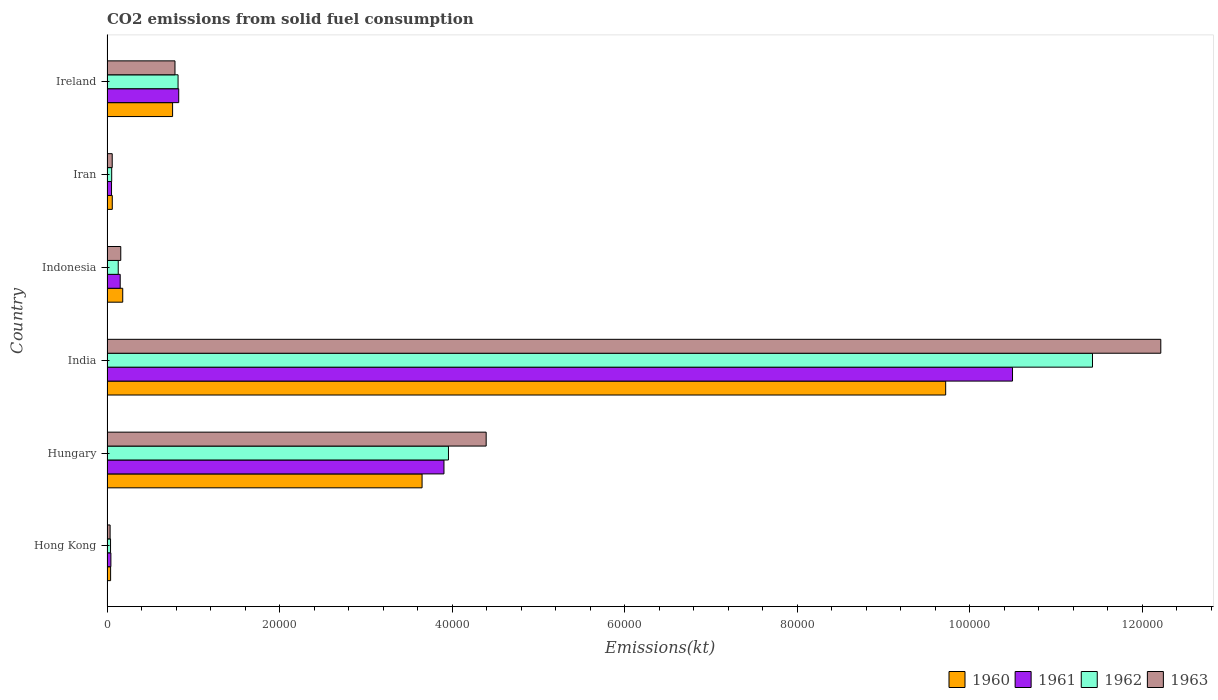How many different coloured bars are there?
Provide a short and direct response. 4. Are the number of bars on each tick of the Y-axis equal?
Your answer should be very brief. Yes. How many bars are there on the 3rd tick from the bottom?
Offer a terse response. 4. What is the amount of CO2 emitted in 1961 in India?
Give a very brief answer. 1.05e+05. Across all countries, what is the maximum amount of CO2 emitted in 1961?
Your response must be concise. 1.05e+05. Across all countries, what is the minimum amount of CO2 emitted in 1963?
Keep it short and to the point. 359.37. In which country was the amount of CO2 emitted in 1961 minimum?
Keep it short and to the point. Hong Kong. What is the total amount of CO2 emitted in 1960 in the graph?
Ensure brevity in your answer.  1.44e+05. What is the difference between the amount of CO2 emitted in 1960 in Hong Kong and that in Indonesia?
Provide a short and direct response. -1404.46. What is the difference between the amount of CO2 emitted in 1962 in India and the amount of CO2 emitted in 1960 in Hungary?
Give a very brief answer. 7.77e+04. What is the average amount of CO2 emitted in 1963 per country?
Make the answer very short. 2.94e+04. What is the difference between the amount of CO2 emitted in 1961 and amount of CO2 emitted in 1963 in India?
Provide a short and direct response. -1.72e+04. In how many countries, is the amount of CO2 emitted in 1961 greater than 92000 kt?
Keep it short and to the point. 1. What is the ratio of the amount of CO2 emitted in 1961 in Hungary to that in Indonesia?
Provide a short and direct response. 25.54. Is the amount of CO2 emitted in 1960 in India less than that in Indonesia?
Ensure brevity in your answer.  No. Is the difference between the amount of CO2 emitted in 1961 in India and Iran greater than the difference between the amount of CO2 emitted in 1963 in India and Iran?
Ensure brevity in your answer.  No. What is the difference between the highest and the second highest amount of CO2 emitted in 1962?
Ensure brevity in your answer.  7.46e+04. What is the difference between the highest and the lowest amount of CO2 emitted in 1963?
Your answer should be compact. 1.22e+05. Is the sum of the amount of CO2 emitted in 1963 in India and Iran greater than the maximum amount of CO2 emitted in 1961 across all countries?
Ensure brevity in your answer.  Yes. Is it the case that in every country, the sum of the amount of CO2 emitted in 1963 and amount of CO2 emitted in 1961 is greater than the sum of amount of CO2 emitted in 1962 and amount of CO2 emitted in 1960?
Provide a succinct answer. No. What does the 4th bar from the bottom in Iran represents?
Offer a terse response. 1963. Is it the case that in every country, the sum of the amount of CO2 emitted in 1960 and amount of CO2 emitted in 1962 is greater than the amount of CO2 emitted in 1963?
Offer a very short reply. Yes. Are the values on the major ticks of X-axis written in scientific E-notation?
Ensure brevity in your answer.  No. What is the title of the graph?
Your answer should be compact. CO2 emissions from solid fuel consumption. What is the label or title of the X-axis?
Your response must be concise. Emissions(kt). What is the Emissions(kt) of 1960 in Hong Kong?
Give a very brief answer. 418.04. What is the Emissions(kt) in 1961 in Hong Kong?
Make the answer very short. 451.04. What is the Emissions(kt) in 1962 in Hong Kong?
Your response must be concise. 410.7. What is the Emissions(kt) of 1963 in Hong Kong?
Give a very brief answer. 359.37. What is the Emissions(kt) of 1960 in Hungary?
Make the answer very short. 3.65e+04. What is the Emissions(kt) of 1961 in Hungary?
Give a very brief answer. 3.91e+04. What is the Emissions(kt) in 1962 in Hungary?
Offer a terse response. 3.96e+04. What is the Emissions(kt) in 1963 in Hungary?
Offer a very short reply. 4.39e+04. What is the Emissions(kt) in 1960 in India?
Your answer should be compact. 9.72e+04. What is the Emissions(kt) in 1961 in India?
Your answer should be very brief. 1.05e+05. What is the Emissions(kt) in 1962 in India?
Ensure brevity in your answer.  1.14e+05. What is the Emissions(kt) in 1963 in India?
Make the answer very short. 1.22e+05. What is the Emissions(kt) in 1960 in Indonesia?
Offer a terse response. 1822.5. What is the Emissions(kt) in 1961 in Indonesia?
Give a very brief answer. 1529.14. What is the Emissions(kt) in 1962 in Indonesia?
Your answer should be very brief. 1301.79. What is the Emissions(kt) in 1963 in Indonesia?
Keep it short and to the point. 1595.14. What is the Emissions(kt) in 1960 in Iran?
Offer a terse response. 612.39. What is the Emissions(kt) in 1961 in Iran?
Keep it short and to the point. 524.38. What is the Emissions(kt) in 1962 in Iran?
Provide a succinct answer. 542.72. What is the Emissions(kt) of 1963 in Iran?
Make the answer very short. 605.05. What is the Emissions(kt) of 1960 in Ireland?
Provide a short and direct response. 7601.69. What is the Emissions(kt) of 1961 in Ireland?
Offer a very short reply. 8313.09. What is the Emissions(kt) of 1962 in Ireland?
Offer a very short reply. 8236.08. What is the Emissions(kt) in 1963 in Ireland?
Provide a succinct answer. 7880.38. Across all countries, what is the maximum Emissions(kt) in 1960?
Ensure brevity in your answer.  9.72e+04. Across all countries, what is the maximum Emissions(kt) of 1961?
Your response must be concise. 1.05e+05. Across all countries, what is the maximum Emissions(kt) in 1962?
Offer a terse response. 1.14e+05. Across all countries, what is the maximum Emissions(kt) of 1963?
Provide a short and direct response. 1.22e+05. Across all countries, what is the minimum Emissions(kt) of 1960?
Your answer should be very brief. 418.04. Across all countries, what is the minimum Emissions(kt) in 1961?
Provide a short and direct response. 451.04. Across all countries, what is the minimum Emissions(kt) of 1962?
Make the answer very short. 410.7. Across all countries, what is the minimum Emissions(kt) in 1963?
Make the answer very short. 359.37. What is the total Emissions(kt) in 1960 in the graph?
Provide a short and direct response. 1.44e+05. What is the total Emissions(kt) in 1961 in the graph?
Make the answer very short. 1.55e+05. What is the total Emissions(kt) in 1962 in the graph?
Your answer should be compact. 1.64e+05. What is the total Emissions(kt) in 1963 in the graph?
Offer a very short reply. 1.77e+05. What is the difference between the Emissions(kt) of 1960 in Hong Kong and that in Hungary?
Your answer should be very brief. -3.61e+04. What is the difference between the Emissions(kt) in 1961 in Hong Kong and that in Hungary?
Keep it short and to the point. -3.86e+04. What is the difference between the Emissions(kt) in 1962 in Hong Kong and that in Hungary?
Offer a terse response. -3.92e+04. What is the difference between the Emissions(kt) of 1963 in Hong Kong and that in Hungary?
Keep it short and to the point. -4.36e+04. What is the difference between the Emissions(kt) in 1960 in Hong Kong and that in India?
Keep it short and to the point. -9.68e+04. What is the difference between the Emissions(kt) of 1961 in Hong Kong and that in India?
Ensure brevity in your answer.  -1.05e+05. What is the difference between the Emissions(kt) of 1962 in Hong Kong and that in India?
Offer a very short reply. -1.14e+05. What is the difference between the Emissions(kt) of 1963 in Hong Kong and that in India?
Your answer should be very brief. -1.22e+05. What is the difference between the Emissions(kt) in 1960 in Hong Kong and that in Indonesia?
Your response must be concise. -1404.46. What is the difference between the Emissions(kt) of 1961 in Hong Kong and that in Indonesia?
Your response must be concise. -1078.1. What is the difference between the Emissions(kt) of 1962 in Hong Kong and that in Indonesia?
Offer a terse response. -891.08. What is the difference between the Emissions(kt) in 1963 in Hong Kong and that in Indonesia?
Your response must be concise. -1235.78. What is the difference between the Emissions(kt) of 1960 in Hong Kong and that in Iran?
Offer a very short reply. -194.35. What is the difference between the Emissions(kt) of 1961 in Hong Kong and that in Iran?
Ensure brevity in your answer.  -73.34. What is the difference between the Emissions(kt) of 1962 in Hong Kong and that in Iran?
Provide a succinct answer. -132.01. What is the difference between the Emissions(kt) of 1963 in Hong Kong and that in Iran?
Your answer should be compact. -245.69. What is the difference between the Emissions(kt) in 1960 in Hong Kong and that in Ireland?
Your answer should be very brief. -7183.65. What is the difference between the Emissions(kt) of 1961 in Hong Kong and that in Ireland?
Give a very brief answer. -7862.05. What is the difference between the Emissions(kt) of 1962 in Hong Kong and that in Ireland?
Your response must be concise. -7825.38. What is the difference between the Emissions(kt) of 1963 in Hong Kong and that in Ireland?
Make the answer very short. -7521.02. What is the difference between the Emissions(kt) in 1960 in Hungary and that in India?
Provide a short and direct response. -6.07e+04. What is the difference between the Emissions(kt) of 1961 in Hungary and that in India?
Your response must be concise. -6.59e+04. What is the difference between the Emissions(kt) of 1962 in Hungary and that in India?
Give a very brief answer. -7.46e+04. What is the difference between the Emissions(kt) of 1963 in Hungary and that in India?
Your response must be concise. -7.82e+04. What is the difference between the Emissions(kt) in 1960 in Hungary and that in Indonesia?
Ensure brevity in your answer.  3.47e+04. What is the difference between the Emissions(kt) of 1961 in Hungary and that in Indonesia?
Your answer should be very brief. 3.75e+04. What is the difference between the Emissions(kt) in 1962 in Hungary and that in Indonesia?
Provide a short and direct response. 3.83e+04. What is the difference between the Emissions(kt) in 1963 in Hungary and that in Indonesia?
Keep it short and to the point. 4.24e+04. What is the difference between the Emissions(kt) of 1960 in Hungary and that in Iran?
Make the answer very short. 3.59e+04. What is the difference between the Emissions(kt) in 1961 in Hungary and that in Iran?
Provide a short and direct response. 3.85e+04. What is the difference between the Emissions(kt) in 1962 in Hungary and that in Iran?
Your answer should be compact. 3.90e+04. What is the difference between the Emissions(kt) of 1963 in Hungary and that in Iran?
Offer a terse response. 4.33e+04. What is the difference between the Emissions(kt) in 1960 in Hungary and that in Ireland?
Your response must be concise. 2.89e+04. What is the difference between the Emissions(kt) of 1961 in Hungary and that in Ireland?
Your answer should be compact. 3.07e+04. What is the difference between the Emissions(kt) of 1962 in Hungary and that in Ireland?
Your answer should be very brief. 3.13e+04. What is the difference between the Emissions(kt) of 1963 in Hungary and that in Ireland?
Your answer should be very brief. 3.61e+04. What is the difference between the Emissions(kt) in 1960 in India and that in Indonesia?
Your answer should be very brief. 9.54e+04. What is the difference between the Emissions(kt) in 1961 in India and that in Indonesia?
Your answer should be very brief. 1.03e+05. What is the difference between the Emissions(kt) in 1962 in India and that in Indonesia?
Your response must be concise. 1.13e+05. What is the difference between the Emissions(kt) in 1963 in India and that in Indonesia?
Provide a succinct answer. 1.21e+05. What is the difference between the Emissions(kt) of 1960 in India and that in Iran?
Keep it short and to the point. 9.66e+04. What is the difference between the Emissions(kt) of 1961 in India and that in Iran?
Provide a short and direct response. 1.04e+05. What is the difference between the Emissions(kt) in 1962 in India and that in Iran?
Offer a terse response. 1.14e+05. What is the difference between the Emissions(kt) of 1963 in India and that in Iran?
Your answer should be very brief. 1.22e+05. What is the difference between the Emissions(kt) in 1960 in India and that in Ireland?
Your answer should be compact. 8.96e+04. What is the difference between the Emissions(kt) in 1961 in India and that in Ireland?
Your answer should be compact. 9.66e+04. What is the difference between the Emissions(kt) of 1962 in India and that in Ireland?
Offer a terse response. 1.06e+05. What is the difference between the Emissions(kt) in 1963 in India and that in Ireland?
Your answer should be very brief. 1.14e+05. What is the difference between the Emissions(kt) in 1960 in Indonesia and that in Iran?
Provide a succinct answer. 1210.11. What is the difference between the Emissions(kt) of 1961 in Indonesia and that in Iran?
Give a very brief answer. 1004.76. What is the difference between the Emissions(kt) in 1962 in Indonesia and that in Iran?
Your response must be concise. 759.07. What is the difference between the Emissions(kt) of 1963 in Indonesia and that in Iran?
Your answer should be compact. 990.09. What is the difference between the Emissions(kt) of 1960 in Indonesia and that in Ireland?
Provide a short and direct response. -5779.19. What is the difference between the Emissions(kt) in 1961 in Indonesia and that in Ireland?
Make the answer very short. -6783.95. What is the difference between the Emissions(kt) in 1962 in Indonesia and that in Ireland?
Your response must be concise. -6934.3. What is the difference between the Emissions(kt) of 1963 in Indonesia and that in Ireland?
Give a very brief answer. -6285.24. What is the difference between the Emissions(kt) of 1960 in Iran and that in Ireland?
Make the answer very short. -6989.3. What is the difference between the Emissions(kt) in 1961 in Iran and that in Ireland?
Provide a succinct answer. -7788.71. What is the difference between the Emissions(kt) of 1962 in Iran and that in Ireland?
Your response must be concise. -7693.37. What is the difference between the Emissions(kt) in 1963 in Iran and that in Ireland?
Your response must be concise. -7275.33. What is the difference between the Emissions(kt) of 1960 in Hong Kong and the Emissions(kt) of 1961 in Hungary?
Your response must be concise. -3.86e+04. What is the difference between the Emissions(kt) in 1960 in Hong Kong and the Emissions(kt) in 1962 in Hungary?
Make the answer very short. -3.92e+04. What is the difference between the Emissions(kt) in 1960 in Hong Kong and the Emissions(kt) in 1963 in Hungary?
Provide a succinct answer. -4.35e+04. What is the difference between the Emissions(kt) in 1961 in Hong Kong and the Emissions(kt) in 1962 in Hungary?
Give a very brief answer. -3.91e+04. What is the difference between the Emissions(kt) in 1961 in Hong Kong and the Emissions(kt) in 1963 in Hungary?
Give a very brief answer. -4.35e+04. What is the difference between the Emissions(kt) in 1962 in Hong Kong and the Emissions(kt) in 1963 in Hungary?
Your answer should be very brief. -4.35e+04. What is the difference between the Emissions(kt) of 1960 in Hong Kong and the Emissions(kt) of 1961 in India?
Your answer should be very brief. -1.05e+05. What is the difference between the Emissions(kt) of 1960 in Hong Kong and the Emissions(kt) of 1962 in India?
Give a very brief answer. -1.14e+05. What is the difference between the Emissions(kt) of 1960 in Hong Kong and the Emissions(kt) of 1963 in India?
Make the answer very short. -1.22e+05. What is the difference between the Emissions(kt) in 1961 in Hong Kong and the Emissions(kt) in 1962 in India?
Offer a terse response. -1.14e+05. What is the difference between the Emissions(kt) in 1961 in Hong Kong and the Emissions(kt) in 1963 in India?
Keep it short and to the point. -1.22e+05. What is the difference between the Emissions(kt) of 1962 in Hong Kong and the Emissions(kt) of 1963 in India?
Give a very brief answer. -1.22e+05. What is the difference between the Emissions(kt) of 1960 in Hong Kong and the Emissions(kt) of 1961 in Indonesia?
Give a very brief answer. -1111.1. What is the difference between the Emissions(kt) of 1960 in Hong Kong and the Emissions(kt) of 1962 in Indonesia?
Make the answer very short. -883.75. What is the difference between the Emissions(kt) of 1960 in Hong Kong and the Emissions(kt) of 1963 in Indonesia?
Offer a very short reply. -1177.11. What is the difference between the Emissions(kt) in 1961 in Hong Kong and the Emissions(kt) in 1962 in Indonesia?
Offer a terse response. -850.74. What is the difference between the Emissions(kt) in 1961 in Hong Kong and the Emissions(kt) in 1963 in Indonesia?
Ensure brevity in your answer.  -1144.1. What is the difference between the Emissions(kt) in 1962 in Hong Kong and the Emissions(kt) in 1963 in Indonesia?
Your response must be concise. -1184.44. What is the difference between the Emissions(kt) of 1960 in Hong Kong and the Emissions(kt) of 1961 in Iran?
Make the answer very short. -106.34. What is the difference between the Emissions(kt) of 1960 in Hong Kong and the Emissions(kt) of 1962 in Iran?
Provide a short and direct response. -124.68. What is the difference between the Emissions(kt) of 1960 in Hong Kong and the Emissions(kt) of 1963 in Iran?
Give a very brief answer. -187.02. What is the difference between the Emissions(kt) of 1961 in Hong Kong and the Emissions(kt) of 1962 in Iran?
Give a very brief answer. -91.67. What is the difference between the Emissions(kt) of 1961 in Hong Kong and the Emissions(kt) of 1963 in Iran?
Give a very brief answer. -154.01. What is the difference between the Emissions(kt) of 1962 in Hong Kong and the Emissions(kt) of 1963 in Iran?
Offer a very short reply. -194.35. What is the difference between the Emissions(kt) of 1960 in Hong Kong and the Emissions(kt) of 1961 in Ireland?
Keep it short and to the point. -7895.05. What is the difference between the Emissions(kt) in 1960 in Hong Kong and the Emissions(kt) in 1962 in Ireland?
Your answer should be very brief. -7818.04. What is the difference between the Emissions(kt) in 1960 in Hong Kong and the Emissions(kt) in 1963 in Ireland?
Make the answer very short. -7462.35. What is the difference between the Emissions(kt) in 1961 in Hong Kong and the Emissions(kt) in 1962 in Ireland?
Make the answer very short. -7785.04. What is the difference between the Emissions(kt) in 1961 in Hong Kong and the Emissions(kt) in 1963 in Ireland?
Ensure brevity in your answer.  -7429.34. What is the difference between the Emissions(kt) of 1962 in Hong Kong and the Emissions(kt) of 1963 in Ireland?
Ensure brevity in your answer.  -7469.68. What is the difference between the Emissions(kt) in 1960 in Hungary and the Emissions(kt) in 1961 in India?
Make the answer very short. -6.84e+04. What is the difference between the Emissions(kt) of 1960 in Hungary and the Emissions(kt) of 1962 in India?
Offer a terse response. -7.77e+04. What is the difference between the Emissions(kt) of 1960 in Hungary and the Emissions(kt) of 1963 in India?
Your answer should be very brief. -8.56e+04. What is the difference between the Emissions(kt) of 1961 in Hungary and the Emissions(kt) of 1962 in India?
Offer a very short reply. -7.52e+04. What is the difference between the Emissions(kt) in 1961 in Hungary and the Emissions(kt) in 1963 in India?
Ensure brevity in your answer.  -8.31e+04. What is the difference between the Emissions(kt) of 1962 in Hungary and the Emissions(kt) of 1963 in India?
Offer a very short reply. -8.26e+04. What is the difference between the Emissions(kt) of 1960 in Hungary and the Emissions(kt) of 1961 in Indonesia?
Your response must be concise. 3.50e+04. What is the difference between the Emissions(kt) in 1960 in Hungary and the Emissions(kt) in 1962 in Indonesia?
Offer a very short reply. 3.52e+04. What is the difference between the Emissions(kt) of 1960 in Hungary and the Emissions(kt) of 1963 in Indonesia?
Make the answer very short. 3.49e+04. What is the difference between the Emissions(kt) in 1961 in Hungary and the Emissions(kt) in 1962 in Indonesia?
Provide a short and direct response. 3.78e+04. What is the difference between the Emissions(kt) in 1961 in Hungary and the Emissions(kt) in 1963 in Indonesia?
Offer a very short reply. 3.75e+04. What is the difference between the Emissions(kt) in 1962 in Hungary and the Emissions(kt) in 1963 in Indonesia?
Ensure brevity in your answer.  3.80e+04. What is the difference between the Emissions(kt) of 1960 in Hungary and the Emissions(kt) of 1961 in Iran?
Ensure brevity in your answer.  3.60e+04. What is the difference between the Emissions(kt) in 1960 in Hungary and the Emissions(kt) in 1962 in Iran?
Ensure brevity in your answer.  3.60e+04. What is the difference between the Emissions(kt) in 1960 in Hungary and the Emissions(kt) in 1963 in Iran?
Your answer should be very brief. 3.59e+04. What is the difference between the Emissions(kt) in 1961 in Hungary and the Emissions(kt) in 1962 in Iran?
Offer a very short reply. 3.85e+04. What is the difference between the Emissions(kt) of 1961 in Hungary and the Emissions(kt) of 1963 in Iran?
Make the answer very short. 3.85e+04. What is the difference between the Emissions(kt) in 1962 in Hungary and the Emissions(kt) in 1963 in Iran?
Provide a short and direct response. 3.90e+04. What is the difference between the Emissions(kt) in 1960 in Hungary and the Emissions(kt) in 1961 in Ireland?
Keep it short and to the point. 2.82e+04. What is the difference between the Emissions(kt) of 1960 in Hungary and the Emissions(kt) of 1962 in Ireland?
Provide a short and direct response. 2.83e+04. What is the difference between the Emissions(kt) in 1960 in Hungary and the Emissions(kt) in 1963 in Ireland?
Your response must be concise. 2.86e+04. What is the difference between the Emissions(kt) in 1961 in Hungary and the Emissions(kt) in 1962 in Ireland?
Your response must be concise. 3.08e+04. What is the difference between the Emissions(kt) of 1961 in Hungary and the Emissions(kt) of 1963 in Ireland?
Offer a very short reply. 3.12e+04. What is the difference between the Emissions(kt) of 1962 in Hungary and the Emissions(kt) of 1963 in Ireland?
Make the answer very short. 3.17e+04. What is the difference between the Emissions(kt) in 1960 in India and the Emissions(kt) in 1961 in Indonesia?
Make the answer very short. 9.57e+04. What is the difference between the Emissions(kt) in 1960 in India and the Emissions(kt) in 1962 in Indonesia?
Keep it short and to the point. 9.59e+04. What is the difference between the Emissions(kt) of 1960 in India and the Emissions(kt) of 1963 in Indonesia?
Your answer should be compact. 9.56e+04. What is the difference between the Emissions(kt) in 1961 in India and the Emissions(kt) in 1962 in Indonesia?
Your answer should be very brief. 1.04e+05. What is the difference between the Emissions(kt) in 1961 in India and the Emissions(kt) in 1963 in Indonesia?
Make the answer very short. 1.03e+05. What is the difference between the Emissions(kt) in 1962 in India and the Emissions(kt) in 1963 in Indonesia?
Provide a short and direct response. 1.13e+05. What is the difference between the Emissions(kt) of 1960 in India and the Emissions(kt) of 1961 in Iran?
Keep it short and to the point. 9.67e+04. What is the difference between the Emissions(kt) in 1960 in India and the Emissions(kt) in 1962 in Iran?
Your response must be concise. 9.67e+04. What is the difference between the Emissions(kt) in 1960 in India and the Emissions(kt) in 1963 in Iran?
Your answer should be compact. 9.66e+04. What is the difference between the Emissions(kt) in 1961 in India and the Emissions(kt) in 1962 in Iran?
Offer a terse response. 1.04e+05. What is the difference between the Emissions(kt) of 1961 in India and the Emissions(kt) of 1963 in Iran?
Keep it short and to the point. 1.04e+05. What is the difference between the Emissions(kt) in 1962 in India and the Emissions(kt) in 1963 in Iran?
Provide a short and direct response. 1.14e+05. What is the difference between the Emissions(kt) of 1960 in India and the Emissions(kt) of 1961 in Ireland?
Make the answer very short. 8.89e+04. What is the difference between the Emissions(kt) of 1960 in India and the Emissions(kt) of 1962 in Ireland?
Make the answer very short. 8.90e+04. What is the difference between the Emissions(kt) of 1960 in India and the Emissions(kt) of 1963 in Ireland?
Offer a very short reply. 8.93e+04. What is the difference between the Emissions(kt) of 1961 in India and the Emissions(kt) of 1962 in Ireland?
Your answer should be very brief. 9.67e+04. What is the difference between the Emissions(kt) in 1961 in India and the Emissions(kt) in 1963 in Ireland?
Keep it short and to the point. 9.71e+04. What is the difference between the Emissions(kt) in 1962 in India and the Emissions(kt) in 1963 in Ireland?
Keep it short and to the point. 1.06e+05. What is the difference between the Emissions(kt) of 1960 in Indonesia and the Emissions(kt) of 1961 in Iran?
Make the answer very short. 1298.12. What is the difference between the Emissions(kt) in 1960 in Indonesia and the Emissions(kt) in 1962 in Iran?
Provide a succinct answer. 1279.78. What is the difference between the Emissions(kt) in 1960 in Indonesia and the Emissions(kt) in 1963 in Iran?
Your answer should be very brief. 1217.44. What is the difference between the Emissions(kt) of 1961 in Indonesia and the Emissions(kt) of 1962 in Iran?
Your answer should be compact. 986.42. What is the difference between the Emissions(kt) of 1961 in Indonesia and the Emissions(kt) of 1963 in Iran?
Provide a succinct answer. 924.08. What is the difference between the Emissions(kt) of 1962 in Indonesia and the Emissions(kt) of 1963 in Iran?
Provide a succinct answer. 696.73. What is the difference between the Emissions(kt) in 1960 in Indonesia and the Emissions(kt) in 1961 in Ireland?
Your answer should be very brief. -6490.59. What is the difference between the Emissions(kt) of 1960 in Indonesia and the Emissions(kt) of 1962 in Ireland?
Offer a terse response. -6413.58. What is the difference between the Emissions(kt) in 1960 in Indonesia and the Emissions(kt) in 1963 in Ireland?
Ensure brevity in your answer.  -6057.88. What is the difference between the Emissions(kt) in 1961 in Indonesia and the Emissions(kt) in 1962 in Ireland?
Ensure brevity in your answer.  -6706.94. What is the difference between the Emissions(kt) of 1961 in Indonesia and the Emissions(kt) of 1963 in Ireland?
Keep it short and to the point. -6351.24. What is the difference between the Emissions(kt) in 1962 in Indonesia and the Emissions(kt) in 1963 in Ireland?
Your answer should be very brief. -6578.6. What is the difference between the Emissions(kt) in 1960 in Iran and the Emissions(kt) in 1961 in Ireland?
Offer a very short reply. -7700.7. What is the difference between the Emissions(kt) in 1960 in Iran and the Emissions(kt) in 1962 in Ireland?
Your answer should be very brief. -7623.69. What is the difference between the Emissions(kt) in 1960 in Iran and the Emissions(kt) in 1963 in Ireland?
Ensure brevity in your answer.  -7267.99. What is the difference between the Emissions(kt) in 1961 in Iran and the Emissions(kt) in 1962 in Ireland?
Provide a succinct answer. -7711.7. What is the difference between the Emissions(kt) in 1961 in Iran and the Emissions(kt) in 1963 in Ireland?
Provide a succinct answer. -7356. What is the difference between the Emissions(kt) in 1962 in Iran and the Emissions(kt) in 1963 in Ireland?
Your answer should be compact. -7337.67. What is the average Emissions(kt) of 1960 per country?
Keep it short and to the point. 2.40e+04. What is the average Emissions(kt) of 1961 per country?
Your response must be concise. 2.58e+04. What is the average Emissions(kt) of 1962 per country?
Your answer should be compact. 2.74e+04. What is the average Emissions(kt) of 1963 per country?
Your answer should be very brief. 2.94e+04. What is the difference between the Emissions(kt) in 1960 and Emissions(kt) in 1961 in Hong Kong?
Provide a short and direct response. -33. What is the difference between the Emissions(kt) of 1960 and Emissions(kt) of 1962 in Hong Kong?
Provide a short and direct response. 7.33. What is the difference between the Emissions(kt) in 1960 and Emissions(kt) in 1963 in Hong Kong?
Make the answer very short. 58.67. What is the difference between the Emissions(kt) of 1961 and Emissions(kt) of 1962 in Hong Kong?
Provide a short and direct response. 40.34. What is the difference between the Emissions(kt) of 1961 and Emissions(kt) of 1963 in Hong Kong?
Your response must be concise. 91.67. What is the difference between the Emissions(kt) of 1962 and Emissions(kt) of 1963 in Hong Kong?
Provide a succinct answer. 51.34. What is the difference between the Emissions(kt) of 1960 and Emissions(kt) of 1961 in Hungary?
Make the answer very short. -2537.56. What is the difference between the Emissions(kt) of 1960 and Emissions(kt) of 1962 in Hungary?
Your answer should be very brief. -3058.28. What is the difference between the Emissions(kt) of 1960 and Emissions(kt) of 1963 in Hungary?
Offer a terse response. -7429.34. What is the difference between the Emissions(kt) in 1961 and Emissions(kt) in 1962 in Hungary?
Offer a very short reply. -520.71. What is the difference between the Emissions(kt) of 1961 and Emissions(kt) of 1963 in Hungary?
Offer a very short reply. -4891.78. What is the difference between the Emissions(kt) in 1962 and Emissions(kt) in 1963 in Hungary?
Give a very brief answer. -4371.06. What is the difference between the Emissions(kt) in 1960 and Emissions(kt) in 1961 in India?
Your answer should be compact. -7748.37. What is the difference between the Emissions(kt) in 1960 and Emissions(kt) in 1962 in India?
Ensure brevity in your answer.  -1.70e+04. What is the difference between the Emissions(kt) in 1960 and Emissions(kt) in 1963 in India?
Make the answer very short. -2.49e+04. What is the difference between the Emissions(kt) of 1961 and Emissions(kt) of 1962 in India?
Make the answer very short. -9270.18. What is the difference between the Emissions(kt) of 1961 and Emissions(kt) of 1963 in India?
Offer a terse response. -1.72e+04. What is the difference between the Emissions(kt) in 1962 and Emissions(kt) in 1963 in India?
Provide a succinct answer. -7917.05. What is the difference between the Emissions(kt) in 1960 and Emissions(kt) in 1961 in Indonesia?
Ensure brevity in your answer.  293.36. What is the difference between the Emissions(kt) of 1960 and Emissions(kt) of 1962 in Indonesia?
Keep it short and to the point. 520.71. What is the difference between the Emissions(kt) of 1960 and Emissions(kt) of 1963 in Indonesia?
Your response must be concise. 227.35. What is the difference between the Emissions(kt) of 1961 and Emissions(kt) of 1962 in Indonesia?
Provide a succinct answer. 227.35. What is the difference between the Emissions(kt) in 1961 and Emissions(kt) in 1963 in Indonesia?
Give a very brief answer. -66.01. What is the difference between the Emissions(kt) of 1962 and Emissions(kt) of 1963 in Indonesia?
Make the answer very short. -293.36. What is the difference between the Emissions(kt) of 1960 and Emissions(kt) of 1961 in Iran?
Your answer should be very brief. 88.01. What is the difference between the Emissions(kt) of 1960 and Emissions(kt) of 1962 in Iran?
Offer a very short reply. 69.67. What is the difference between the Emissions(kt) of 1960 and Emissions(kt) of 1963 in Iran?
Your answer should be very brief. 7.33. What is the difference between the Emissions(kt) in 1961 and Emissions(kt) in 1962 in Iran?
Your answer should be compact. -18.34. What is the difference between the Emissions(kt) in 1961 and Emissions(kt) in 1963 in Iran?
Give a very brief answer. -80.67. What is the difference between the Emissions(kt) of 1962 and Emissions(kt) of 1963 in Iran?
Provide a short and direct response. -62.34. What is the difference between the Emissions(kt) of 1960 and Emissions(kt) of 1961 in Ireland?
Your answer should be compact. -711.4. What is the difference between the Emissions(kt) in 1960 and Emissions(kt) in 1962 in Ireland?
Provide a short and direct response. -634.39. What is the difference between the Emissions(kt) in 1960 and Emissions(kt) in 1963 in Ireland?
Offer a very short reply. -278.69. What is the difference between the Emissions(kt) of 1961 and Emissions(kt) of 1962 in Ireland?
Give a very brief answer. 77.01. What is the difference between the Emissions(kt) in 1961 and Emissions(kt) in 1963 in Ireland?
Provide a succinct answer. 432.71. What is the difference between the Emissions(kt) of 1962 and Emissions(kt) of 1963 in Ireland?
Make the answer very short. 355.7. What is the ratio of the Emissions(kt) in 1960 in Hong Kong to that in Hungary?
Offer a very short reply. 0.01. What is the ratio of the Emissions(kt) of 1961 in Hong Kong to that in Hungary?
Your answer should be very brief. 0.01. What is the ratio of the Emissions(kt) of 1962 in Hong Kong to that in Hungary?
Keep it short and to the point. 0.01. What is the ratio of the Emissions(kt) of 1963 in Hong Kong to that in Hungary?
Your answer should be very brief. 0.01. What is the ratio of the Emissions(kt) of 1960 in Hong Kong to that in India?
Make the answer very short. 0. What is the ratio of the Emissions(kt) of 1961 in Hong Kong to that in India?
Provide a short and direct response. 0. What is the ratio of the Emissions(kt) in 1962 in Hong Kong to that in India?
Provide a short and direct response. 0. What is the ratio of the Emissions(kt) in 1963 in Hong Kong to that in India?
Your response must be concise. 0. What is the ratio of the Emissions(kt) in 1960 in Hong Kong to that in Indonesia?
Offer a terse response. 0.23. What is the ratio of the Emissions(kt) of 1961 in Hong Kong to that in Indonesia?
Your answer should be compact. 0.29. What is the ratio of the Emissions(kt) in 1962 in Hong Kong to that in Indonesia?
Offer a very short reply. 0.32. What is the ratio of the Emissions(kt) of 1963 in Hong Kong to that in Indonesia?
Make the answer very short. 0.23. What is the ratio of the Emissions(kt) of 1960 in Hong Kong to that in Iran?
Offer a very short reply. 0.68. What is the ratio of the Emissions(kt) in 1961 in Hong Kong to that in Iran?
Offer a terse response. 0.86. What is the ratio of the Emissions(kt) of 1962 in Hong Kong to that in Iran?
Ensure brevity in your answer.  0.76. What is the ratio of the Emissions(kt) of 1963 in Hong Kong to that in Iran?
Offer a very short reply. 0.59. What is the ratio of the Emissions(kt) of 1960 in Hong Kong to that in Ireland?
Keep it short and to the point. 0.06. What is the ratio of the Emissions(kt) of 1961 in Hong Kong to that in Ireland?
Your response must be concise. 0.05. What is the ratio of the Emissions(kt) of 1962 in Hong Kong to that in Ireland?
Your answer should be very brief. 0.05. What is the ratio of the Emissions(kt) in 1963 in Hong Kong to that in Ireland?
Your answer should be very brief. 0.05. What is the ratio of the Emissions(kt) of 1960 in Hungary to that in India?
Offer a terse response. 0.38. What is the ratio of the Emissions(kt) in 1961 in Hungary to that in India?
Keep it short and to the point. 0.37. What is the ratio of the Emissions(kt) of 1962 in Hungary to that in India?
Provide a succinct answer. 0.35. What is the ratio of the Emissions(kt) of 1963 in Hungary to that in India?
Your response must be concise. 0.36. What is the ratio of the Emissions(kt) in 1960 in Hungary to that in Indonesia?
Offer a very short reply. 20.04. What is the ratio of the Emissions(kt) of 1961 in Hungary to that in Indonesia?
Your answer should be compact. 25.54. What is the ratio of the Emissions(kt) in 1962 in Hungary to that in Indonesia?
Ensure brevity in your answer.  30.4. What is the ratio of the Emissions(kt) in 1963 in Hungary to that in Indonesia?
Your response must be concise. 27.55. What is the ratio of the Emissions(kt) in 1960 in Hungary to that in Iran?
Your answer should be very brief. 59.63. What is the ratio of the Emissions(kt) in 1961 in Hungary to that in Iran?
Your answer should be very brief. 74.48. What is the ratio of the Emissions(kt) in 1962 in Hungary to that in Iran?
Provide a succinct answer. 72.93. What is the ratio of the Emissions(kt) of 1963 in Hungary to that in Iran?
Your answer should be very brief. 72.64. What is the ratio of the Emissions(kt) in 1960 in Hungary to that in Ireland?
Make the answer very short. 4.8. What is the ratio of the Emissions(kt) of 1961 in Hungary to that in Ireland?
Ensure brevity in your answer.  4.7. What is the ratio of the Emissions(kt) of 1962 in Hungary to that in Ireland?
Offer a very short reply. 4.81. What is the ratio of the Emissions(kt) of 1963 in Hungary to that in Ireland?
Give a very brief answer. 5.58. What is the ratio of the Emissions(kt) of 1960 in India to that in Indonesia?
Provide a short and direct response. 53.34. What is the ratio of the Emissions(kt) in 1961 in India to that in Indonesia?
Provide a short and direct response. 68.64. What is the ratio of the Emissions(kt) in 1962 in India to that in Indonesia?
Your answer should be very brief. 87.75. What is the ratio of the Emissions(kt) of 1963 in India to that in Indonesia?
Make the answer very short. 76.57. What is the ratio of the Emissions(kt) in 1960 in India to that in Iran?
Offer a very short reply. 158.74. What is the ratio of the Emissions(kt) of 1961 in India to that in Iran?
Make the answer very short. 200.15. What is the ratio of the Emissions(kt) in 1962 in India to that in Iran?
Provide a succinct answer. 210.47. What is the ratio of the Emissions(kt) in 1963 in India to that in Iran?
Ensure brevity in your answer.  201.87. What is the ratio of the Emissions(kt) of 1960 in India to that in Ireland?
Ensure brevity in your answer.  12.79. What is the ratio of the Emissions(kt) in 1961 in India to that in Ireland?
Your answer should be compact. 12.63. What is the ratio of the Emissions(kt) of 1962 in India to that in Ireland?
Your answer should be compact. 13.87. What is the ratio of the Emissions(kt) in 1963 in India to that in Ireland?
Your answer should be very brief. 15.5. What is the ratio of the Emissions(kt) of 1960 in Indonesia to that in Iran?
Your answer should be compact. 2.98. What is the ratio of the Emissions(kt) of 1961 in Indonesia to that in Iran?
Give a very brief answer. 2.92. What is the ratio of the Emissions(kt) in 1962 in Indonesia to that in Iran?
Your answer should be compact. 2.4. What is the ratio of the Emissions(kt) in 1963 in Indonesia to that in Iran?
Offer a terse response. 2.64. What is the ratio of the Emissions(kt) of 1960 in Indonesia to that in Ireland?
Keep it short and to the point. 0.24. What is the ratio of the Emissions(kt) of 1961 in Indonesia to that in Ireland?
Make the answer very short. 0.18. What is the ratio of the Emissions(kt) of 1962 in Indonesia to that in Ireland?
Offer a very short reply. 0.16. What is the ratio of the Emissions(kt) in 1963 in Indonesia to that in Ireland?
Your answer should be compact. 0.2. What is the ratio of the Emissions(kt) in 1960 in Iran to that in Ireland?
Give a very brief answer. 0.08. What is the ratio of the Emissions(kt) of 1961 in Iran to that in Ireland?
Provide a short and direct response. 0.06. What is the ratio of the Emissions(kt) of 1962 in Iran to that in Ireland?
Give a very brief answer. 0.07. What is the ratio of the Emissions(kt) of 1963 in Iran to that in Ireland?
Make the answer very short. 0.08. What is the difference between the highest and the second highest Emissions(kt) in 1960?
Keep it short and to the point. 6.07e+04. What is the difference between the highest and the second highest Emissions(kt) of 1961?
Keep it short and to the point. 6.59e+04. What is the difference between the highest and the second highest Emissions(kt) in 1962?
Give a very brief answer. 7.46e+04. What is the difference between the highest and the second highest Emissions(kt) in 1963?
Your answer should be very brief. 7.82e+04. What is the difference between the highest and the lowest Emissions(kt) of 1960?
Offer a terse response. 9.68e+04. What is the difference between the highest and the lowest Emissions(kt) of 1961?
Make the answer very short. 1.05e+05. What is the difference between the highest and the lowest Emissions(kt) of 1962?
Offer a terse response. 1.14e+05. What is the difference between the highest and the lowest Emissions(kt) in 1963?
Ensure brevity in your answer.  1.22e+05. 